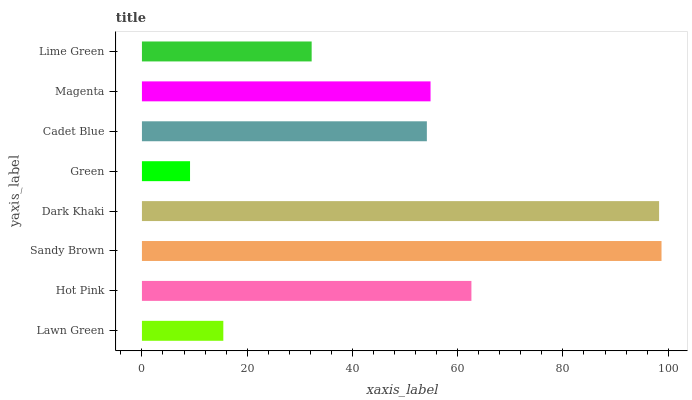Is Green the minimum?
Answer yes or no. Yes. Is Sandy Brown the maximum?
Answer yes or no. Yes. Is Hot Pink the minimum?
Answer yes or no. No. Is Hot Pink the maximum?
Answer yes or no. No. Is Hot Pink greater than Lawn Green?
Answer yes or no. Yes. Is Lawn Green less than Hot Pink?
Answer yes or no. Yes. Is Lawn Green greater than Hot Pink?
Answer yes or no. No. Is Hot Pink less than Lawn Green?
Answer yes or no. No. Is Magenta the high median?
Answer yes or no. Yes. Is Cadet Blue the low median?
Answer yes or no. Yes. Is Cadet Blue the high median?
Answer yes or no. No. Is Magenta the low median?
Answer yes or no. No. 